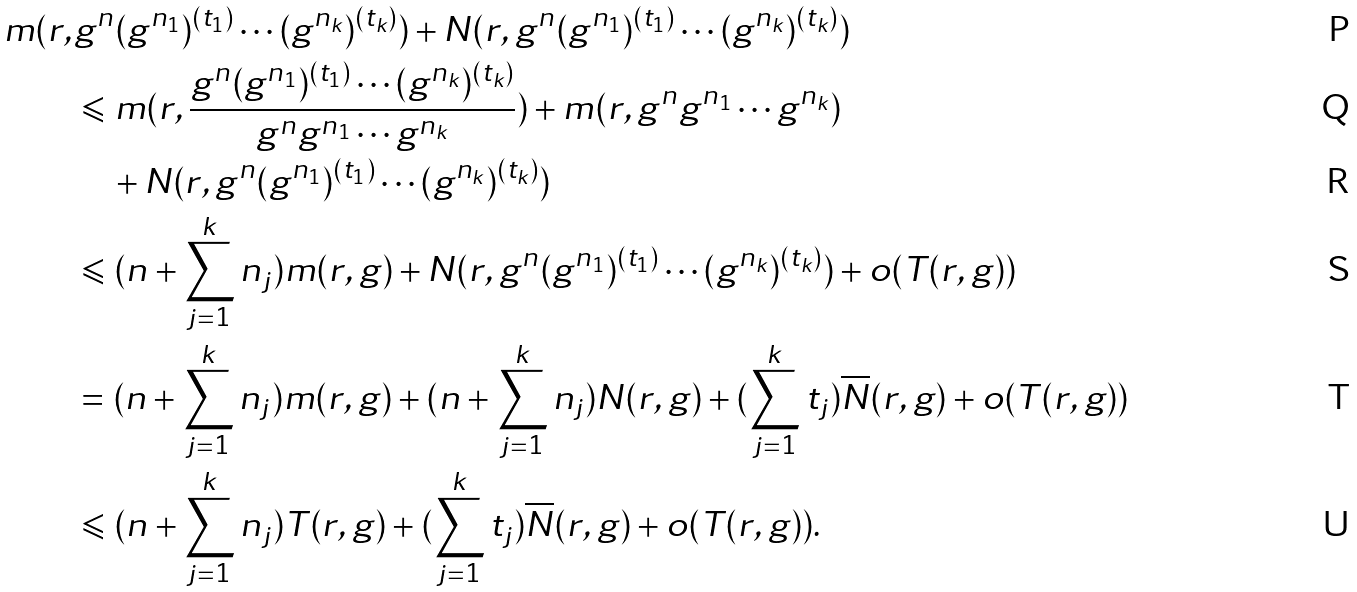Convert formula to latex. <formula><loc_0><loc_0><loc_500><loc_500>m ( r , & g ^ { n } ( g ^ { n _ { 1 } } ) ^ { ( t _ { 1 } ) } \cdots ( g ^ { n _ { k } } ) ^ { ( t _ { k } ) } ) + N ( r , g ^ { n } ( g ^ { n _ { 1 } } ) ^ { ( t _ { 1 } ) } \cdots ( g ^ { n _ { k } } ) ^ { ( t _ { k } ) } ) \\ & \leqslant m ( r , \frac { g ^ { n } ( g ^ { n _ { 1 } } ) ^ { ( t _ { 1 } ) } \cdots ( g ^ { n _ { k } } ) ^ { ( t _ { k } ) } } { g ^ { n } g ^ { n _ { 1 } } \cdots g ^ { n _ { k } } } ) + m ( r , g ^ { n } g ^ { n _ { 1 } } \cdots g ^ { n _ { k } } ) \\ & \quad + N ( r , g ^ { n } ( g ^ { n _ { 1 } } ) ^ { ( t _ { 1 } ) } \cdots ( g ^ { n _ { k } } ) ^ { ( t _ { k } ) } ) \\ & \leqslant ( n + \sum _ { j = 1 } ^ { k } n _ { j } ) m ( r , g ) + N ( r , g ^ { n } ( g ^ { n _ { 1 } } ) ^ { ( t _ { 1 } ) } \cdots ( g ^ { n _ { k } } ) ^ { ( t _ { k } ) } ) + o ( T ( r , g ) ) \\ & = ( n + \sum _ { j = 1 } ^ { k } n _ { j } ) m ( r , g ) + ( n + \sum _ { j = 1 } ^ { k } n _ { j } ) N ( r , g ) + ( \sum _ { j = 1 } ^ { k } t _ { j } ) \overline { N } ( r , g ) + o ( T ( r , g ) ) \\ & \leqslant ( n + \sum _ { j = 1 } ^ { k } n _ { j } ) T ( r , g ) + ( \sum _ { j = 1 } ^ { k } t _ { j } ) \overline { N } ( r , g ) + o ( T ( r , g ) ) .</formula> 